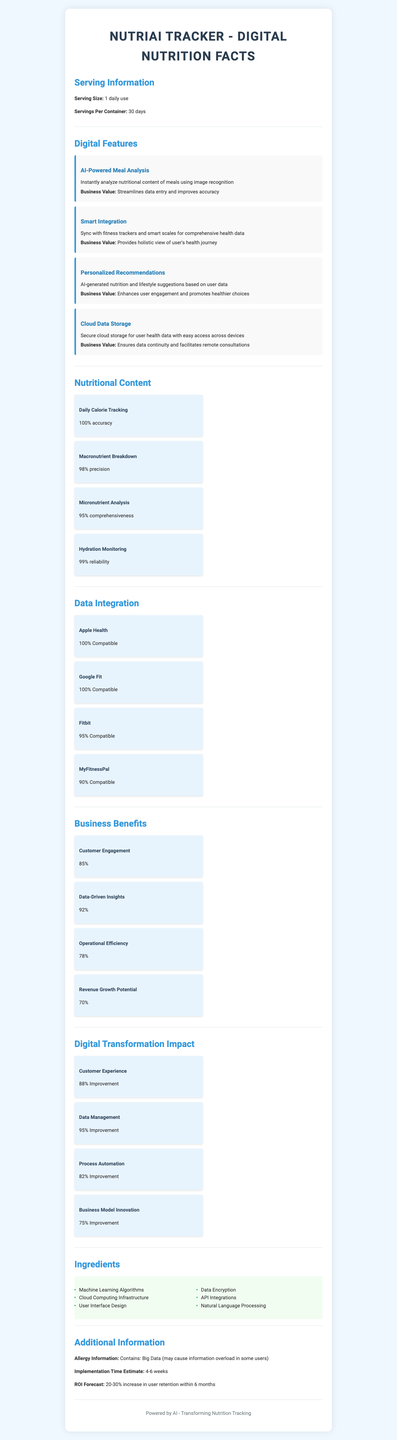what is the serving size? The serving size is provided at the top of the "Serving Information" section as "1 daily use".
Answer: 1 daily use how many days does one container last? The number of servings per container is listed as "30 days" in the "Serving Information" section.
Answer: 30 days which digital feature instantly analyzes the nutritional content of meals? The "Digital Features" section describes "AI-Powered Meal Analysis" as instantly analyzing nutritional content of meals using image recognition.
Answer: AI-Powered Meal Analysis name two sources of compatibility mentioned for data integration. The "Data Integration" section lists several sources of compatibility, including Apple Health and Google Fit, both with 100% compatibility.
Answer: Apple Health and Google Fit what improvement percentage does data management achieve? The "Digital Transformation Impact" section notes that "Data Management" has a "95% Improvement".
Answer: 95% which digital feature enhances user engagement and promotes healthier choices? A. Smart Integration B. AI-Powered Meal Analysis C. Personalized Recommendations The "Digital Features" section describes "Personalized Recommendations" as enhancing user engagement and promoting healthier choices.
Answer: C what percentage improvement is noted under business model innovation? A. 75% B. 78% C. 85% D. 88% The "Digital Transformation Impact" section indicates that "Business Model Innovation" achieves a 75% improvement.
Answer: A is customer engagement affected? The "Business Benefits" section indicates that customer engagement is one of the benefits, with a percentage listed.
Answer: Yes summarize the main aspects covered in the document. The document aims to highlight NutriAI Tracker's features and benefits, showcasing how AI and data integration promote user engagement and provide valuable health insights.
Answer: The NutriAI Tracker digital nutrition facts document provides a comprehensive overview of the serving information, digital features, nutritional content tracking, data integration capabilities, business benefits, digital transformation impact, ingredients, and additional information related to the app's deployment and expected return on investment. what is missing in the list of nutritional content? The document lists various aspects of nutritional content tracking like calorie tracking, macronutrient breakdown, micronutrient analysis, and hydration monitoring, but there's no way to know if any specific item is missing from this list.
Answer: Cannot be determined 